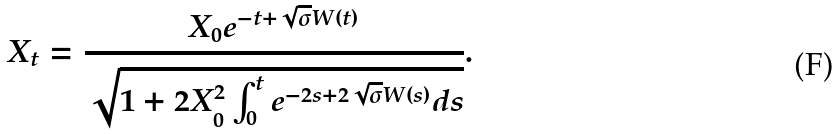<formula> <loc_0><loc_0><loc_500><loc_500>X _ { t } = \frac { X _ { 0 } e ^ { - t + \sqrt { \sigma } W ( t ) } } { \sqrt { 1 + 2 X _ { 0 } ^ { 2 } \int _ { 0 } ^ { t } e ^ { - 2 s + 2 \sqrt { \sigma } W ( s ) } d s } } .</formula> 